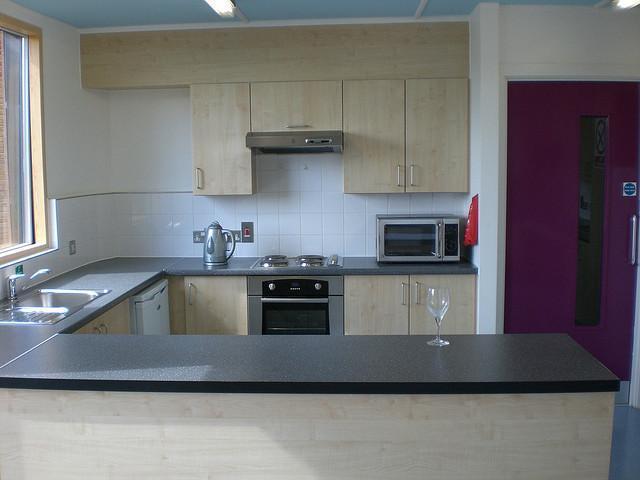What is on top of the counter?
Choose the right answer from the provided options to respond to the question.
Options: Book, television, apple, coffee pot. Coffee pot. 